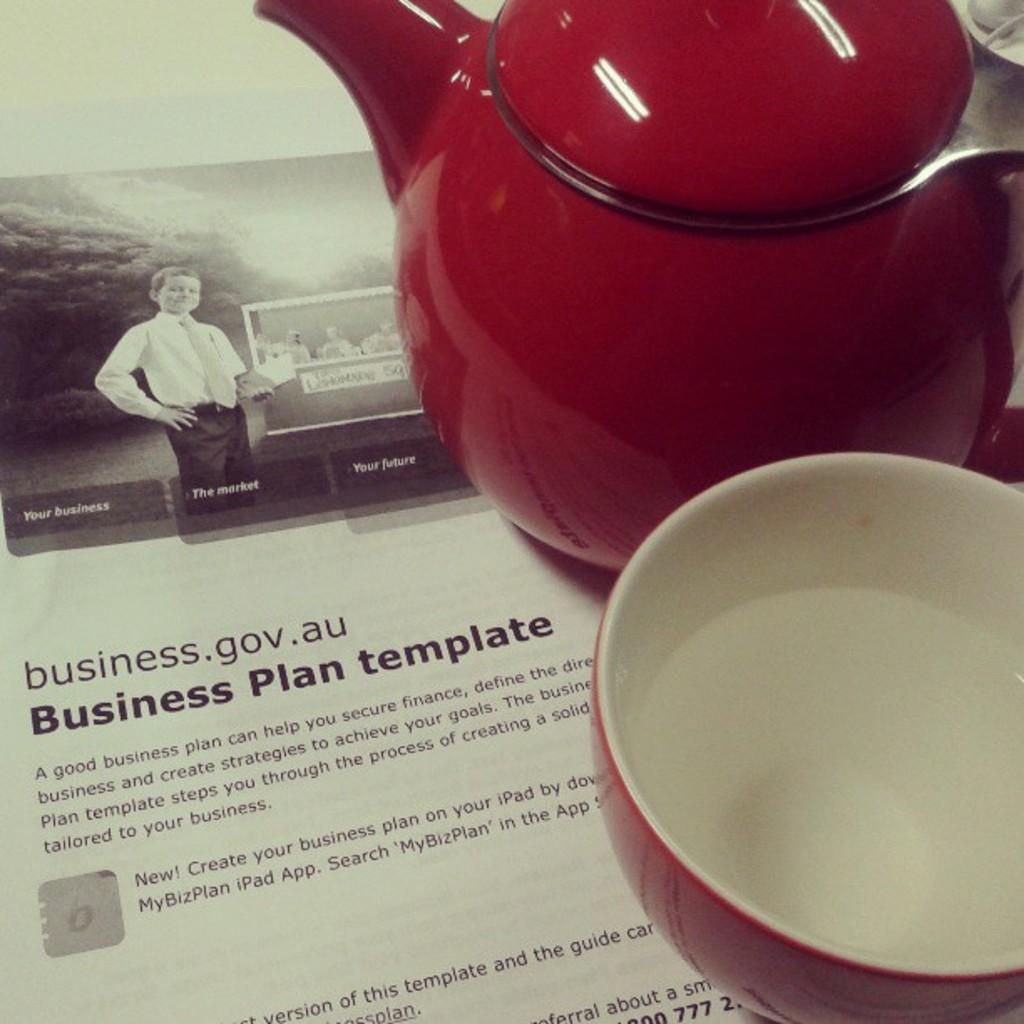What is the main object in the image? There is a kettle in the image. What else can be seen in the image besides the kettle? There is a bowl on a paper in the image, and there is a picture of a kid on the paper. Is there any text on the paper? Yes, there is writing on the paper. How many kittens are playing with the substance on the paper? There are no kittens or substance present in the image. 